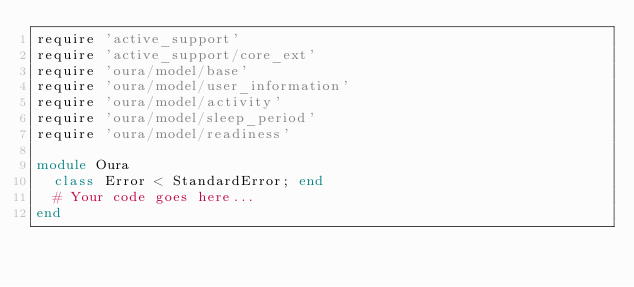Convert code to text. <code><loc_0><loc_0><loc_500><loc_500><_Ruby_>require 'active_support'
require 'active_support/core_ext'
require 'oura/model/base'
require 'oura/model/user_information'
require 'oura/model/activity'
require 'oura/model/sleep_period'
require 'oura/model/readiness'

module Oura
  class Error < StandardError; end
  # Your code goes here...
end
</code> 